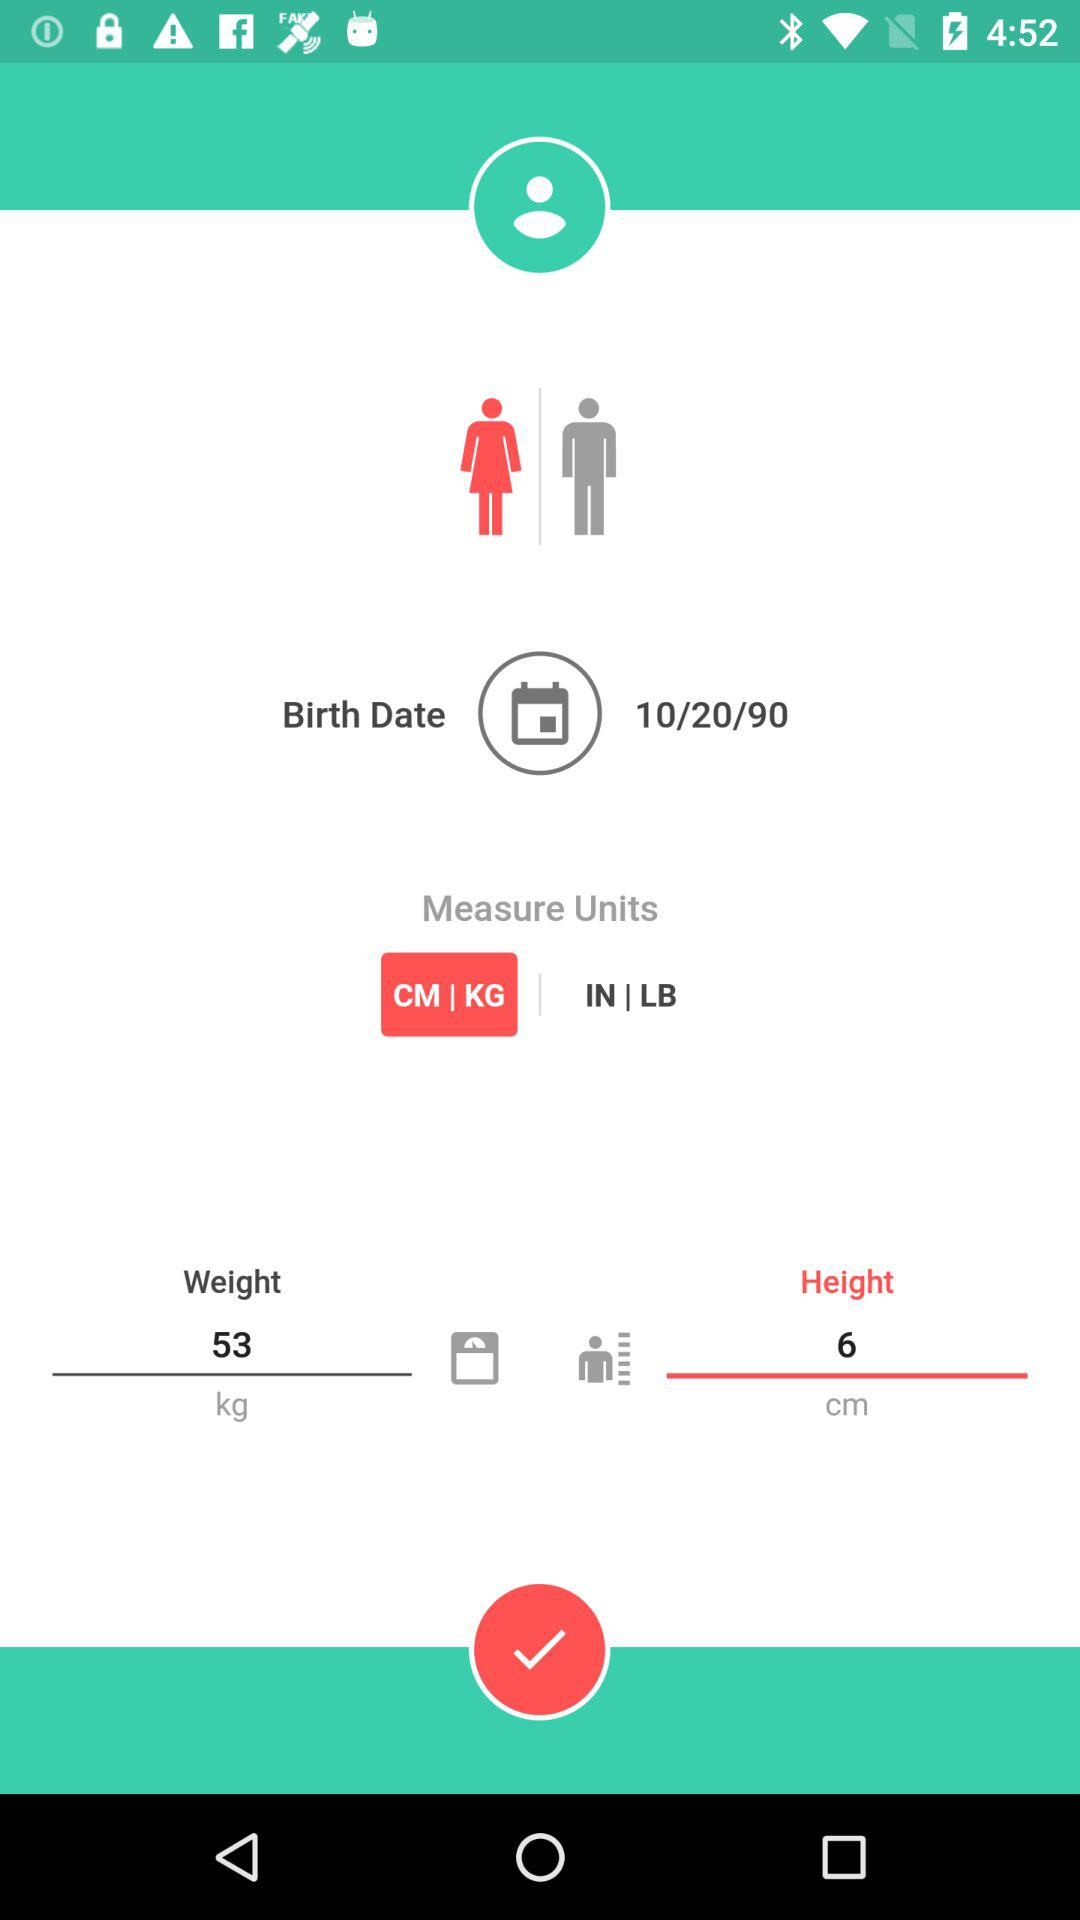What is the selected measuring unit? The selected measuring unit is "CM | KG". 